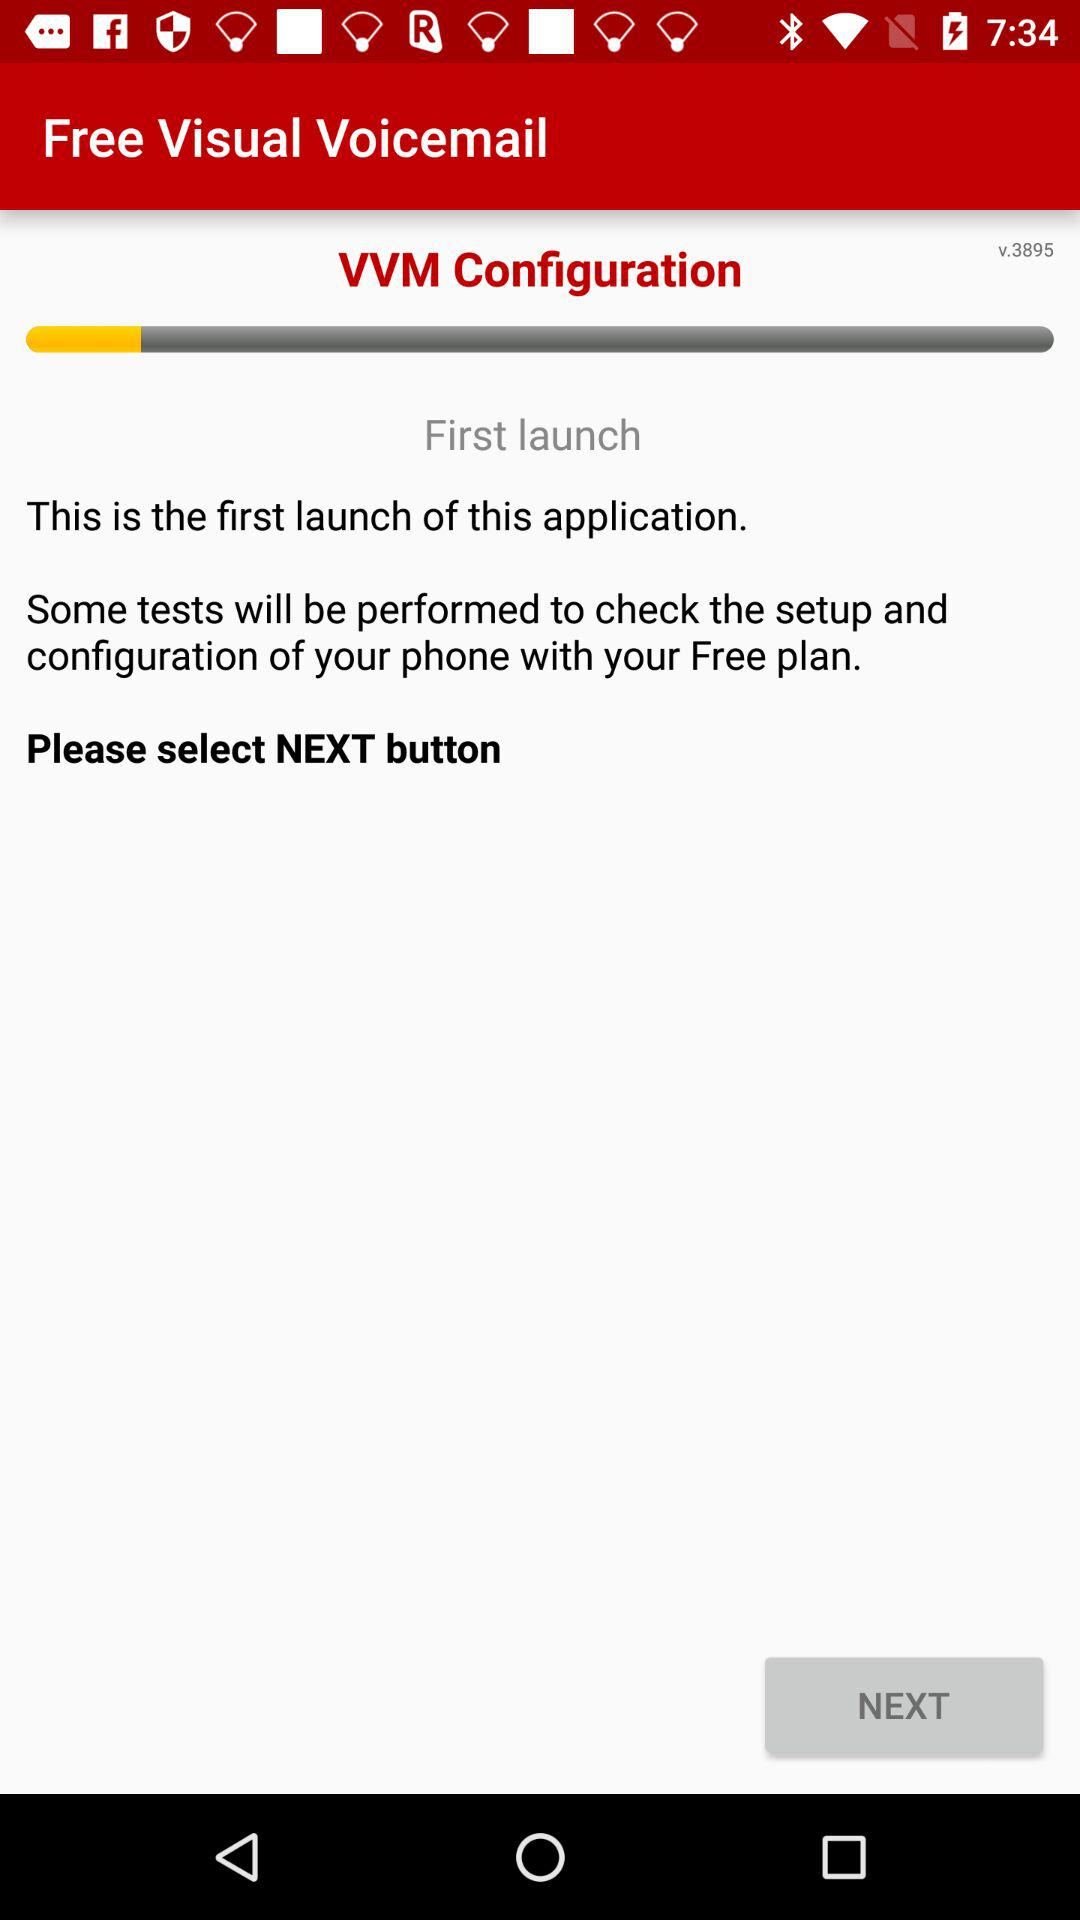Which version is used? The used version is v.3895. 